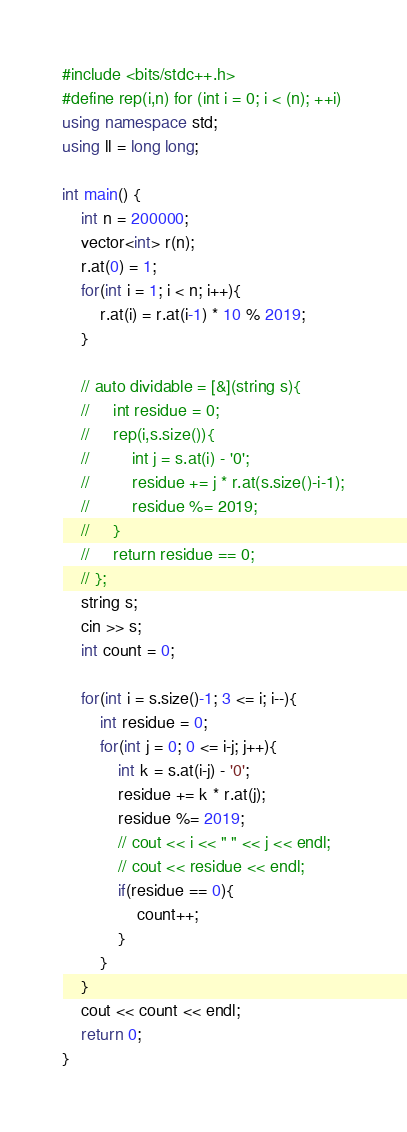<code> <loc_0><loc_0><loc_500><loc_500><_C++_>#include <bits/stdc++.h>
#define rep(i,n) for (int i = 0; i < (n); ++i)
using namespace std;
using ll = long long;

int main() {
    int n = 200000;
    vector<int> r(n);
    r.at(0) = 1;
    for(int i = 1; i < n; i++){
        r.at(i) = r.at(i-1) * 10 % 2019;
    }

    // auto dividable = [&](string s){
    //     int residue = 0;
    //     rep(i,s.size()){
    //         int j = s.at(i) - '0';
    //         residue += j * r.at(s.size()-i-1);
    //         residue %= 2019;
    //     }
    //     return residue == 0;
    // };
    string s;
    cin >> s;
    int count = 0;

    for(int i = s.size()-1; 3 <= i; i--){
        int residue = 0;
        for(int j = 0; 0 <= i-j; j++){
            int k = s.at(i-j) - '0';
            residue += k * r.at(j);
            residue %= 2019;
            // cout << i << " " << j << endl;
            // cout << residue << endl;
            if(residue == 0){
                count++;
            }
        }
    }
    cout << count << endl;
    return 0;
}</code> 